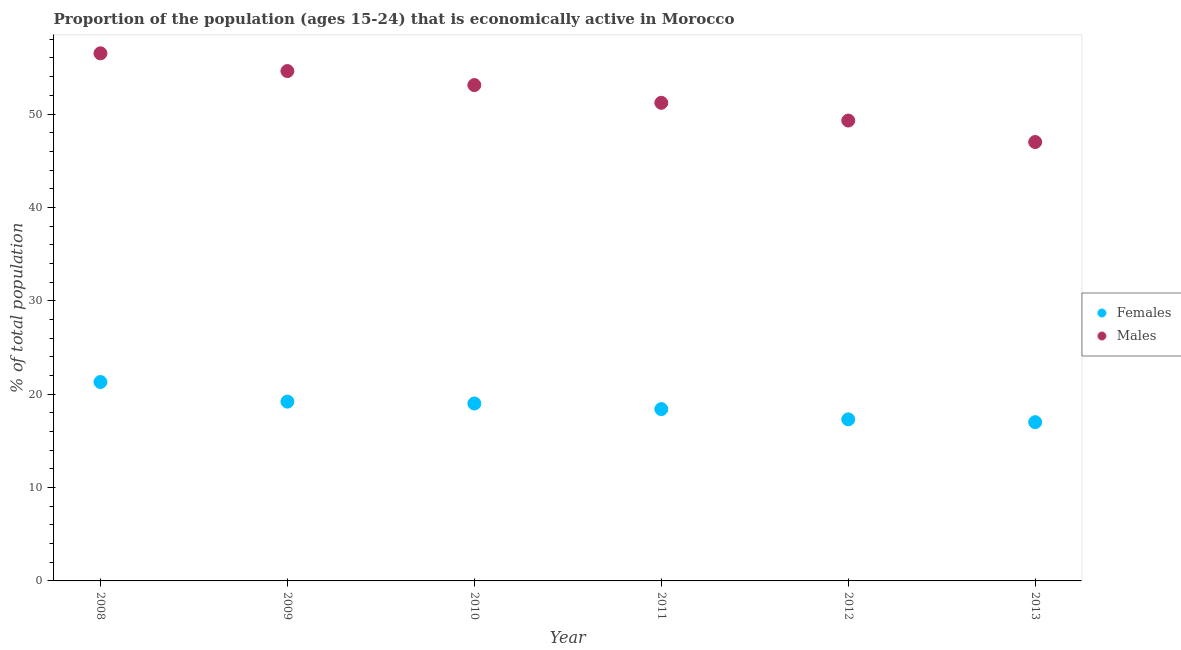How many different coloured dotlines are there?
Keep it short and to the point. 2. What is the percentage of economically active female population in 2008?
Your answer should be very brief. 21.3. Across all years, what is the maximum percentage of economically active male population?
Offer a terse response. 56.5. Across all years, what is the minimum percentage of economically active female population?
Your response must be concise. 17. In which year was the percentage of economically active female population maximum?
Ensure brevity in your answer.  2008. In which year was the percentage of economically active female population minimum?
Offer a very short reply. 2013. What is the total percentage of economically active male population in the graph?
Give a very brief answer. 311.7. What is the difference between the percentage of economically active male population in 2008 and that in 2010?
Keep it short and to the point. 3.4. What is the difference between the percentage of economically active male population in 2010 and the percentage of economically active female population in 2008?
Give a very brief answer. 31.8. What is the average percentage of economically active male population per year?
Give a very brief answer. 51.95. In the year 2011, what is the difference between the percentage of economically active male population and percentage of economically active female population?
Make the answer very short. 32.8. What is the ratio of the percentage of economically active female population in 2010 to that in 2012?
Offer a very short reply. 1.1. What is the difference between the highest and the second highest percentage of economically active female population?
Provide a succinct answer. 2.1. In how many years, is the percentage of economically active male population greater than the average percentage of economically active male population taken over all years?
Provide a succinct answer. 3. Is the sum of the percentage of economically active male population in 2010 and 2013 greater than the maximum percentage of economically active female population across all years?
Give a very brief answer. Yes. Does the percentage of economically active female population monotonically increase over the years?
Offer a very short reply. No. Is the percentage of economically active male population strictly greater than the percentage of economically active female population over the years?
Ensure brevity in your answer.  Yes. How many dotlines are there?
Give a very brief answer. 2. How many years are there in the graph?
Offer a very short reply. 6. Are the values on the major ticks of Y-axis written in scientific E-notation?
Give a very brief answer. No. Does the graph contain any zero values?
Make the answer very short. No. Does the graph contain grids?
Ensure brevity in your answer.  No. Where does the legend appear in the graph?
Your answer should be compact. Center right. What is the title of the graph?
Make the answer very short. Proportion of the population (ages 15-24) that is economically active in Morocco. Does "Primary completion rate" appear as one of the legend labels in the graph?
Provide a short and direct response. No. What is the label or title of the Y-axis?
Keep it short and to the point. % of total population. What is the % of total population of Females in 2008?
Make the answer very short. 21.3. What is the % of total population of Males in 2008?
Give a very brief answer. 56.5. What is the % of total population in Females in 2009?
Keep it short and to the point. 19.2. What is the % of total population of Males in 2009?
Offer a terse response. 54.6. What is the % of total population in Males in 2010?
Your answer should be compact. 53.1. What is the % of total population in Females in 2011?
Make the answer very short. 18.4. What is the % of total population of Males in 2011?
Your response must be concise. 51.2. What is the % of total population of Females in 2012?
Give a very brief answer. 17.3. What is the % of total population of Males in 2012?
Give a very brief answer. 49.3. What is the % of total population of Females in 2013?
Provide a succinct answer. 17. What is the % of total population of Males in 2013?
Offer a very short reply. 47. Across all years, what is the maximum % of total population of Females?
Provide a succinct answer. 21.3. Across all years, what is the maximum % of total population of Males?
Offer a very short reply. 56.5. Across all years, what is the minimum % of total population of Males?
Keep it short and to the point. 47. What is the total % of total population of Females in the graph?
Provide a short and direct response. 112.2. What is the total % of total population of Males in the graph?
Make the answer very short. 311.7. What is the difference between the % of total population of Females in 2008 and that in 2009?
Offer a terse response. 2.1. What is the difference between the % of total population of Males in 2008 and that in 2009?
Keep it short and to the point. 1.9. What is the difference between the % of total population in Females in 2008 and that in 2010?
Offer a terse response. 2.3. What is the difference between the % of total population in Females in 2008 and that in 2011?
Provide a succinct answer. 2.9. What is the difference between the % of total population in Females in 2008 and that in 2012?
Your response must be concise. 4. What is the difference between the % of total population in Females in 2008 and that in 2013?
Your answer should be very brief. 4.3. What is the difference between the % of total population of Females in 2009 and that in 2012?
Make the answer very short. 1.9. What is the difference between the % of total population in Males in 2009 and that in 2012?
Offer a terse response. 5.3. What is the difference between the % of total population in Females in 2009 and that in 2013?
Keep it short and to the point. 2.2. What is the difference between the % of total population of Males in 2009 and that in 2013?
Provide a short and direct response. 7.6. What is the difference between the % of total population of Males in 2010 and that in 2012?
Your answer should be compact. 3.8. What is the difference between the % of total population of Males in 2010 and that in 2013?
Provide a short and direct response. 6.1. What is the difference between the % of total population in Females in 2011 and that in 2012?
Offer a terse response. 1.1. What is the difference between the % of total population of Females in 2012 and that in 2013?
Your response must be concise. 0.3. What is the difference between the % of total population of Males in 2012 and that in 2013?
Your response must be concise. 2.3. What is the difference between the % of total population of Females in 2008 and the % of total population of Males in 2009?
Ensure brevity in your answer.  -33.3. What is the difference between the % of total population in Females in 2008 and the % of total population in Males in 2010?
Ensure brevity in your answer.  -31.8. What is the difference between the % of total population in Females in 2008 and the % of total population in Males in 2011?
Provide a succinct answer. -29.9. What is the difference between the % of total population in Females in 2008 and the % of total population in Males in 2013?
Provide a short and direct response. -25.7. What is the difference between the % of total population in Females in 2009 and the % of total population in Males in 2010?
Offer a terse response. -33.9. What is the difference between the % of total population of Females in 2009 and the % of total population of Males in 2011?
Give a very brief answer. -32. What is the difference between the % of total population of Females in 2009 and the % of total population of Males in 2012?
Keep it short and to the point. -30.1. What is the difference between the % of total population of Females in 2009 and the % of total population of Males in 2013?
Your answer should be compact. -27.8. What is the difference between the % of total population of Females in 2010 and the % of total population of Males in 2011?
Give a very brief answer. -32.2. What is the difference between the % of total population in Females in 2010 and the % of total population in Males in 2012?
Make the answer very short. -30.3. What is the difference between the % of total population in Females in 2010 and the % of total population in Males in 2013?
Give a very brief answer. -28. What is the difference between the % of total population of Females in 2011 and the % of total population of Males in 2012?
Your response must be concise. -30.9. What is the difference between the % of total population in Females in 2011 and the % of total population in Males in 2013?
Offer a terse response. -28.6. What is the difference between the % of total population of Females in 2012 and the % of total population of Males in 2013?
Your answer should be compact. -29.7. What is the average % of total population in Females per year?
Provide a short and direct response. 18.7. What is the average % of total population in Males per year?
Provide a short and direct response. 51.95. In the year 2008, what is the difference between the % of total population in Females and % of total population in Males?
Your response must be concise. -35.2. In the year 2009, what is the difference between the % of total population of Females and % of total population of Males?
Your response must be concise. -35.4. In the year 2010, what is the difference between the % of total population of Females and % of total population of Males?
Provide a succinct answer. -34.1. In the year 2011, what is the difference between the % of total population in Females and % of total population in Males?
Offer a very short reply. -32.8. In the year 2012, what is the difference between the % of total population in Females and % of total population in Males?
Offer a very short reply. -32. What is the ratio of the % of total population in Females in 2008 to that in 2009?
Keep it short and to the point. 1.11. What is the ratio of the % of total population in Males in 2008 to that in 2009?
Your answer should be compact. 1.03. What is the ratio of the % of total population of Females in 2008 to that in 2010?
Offer a terse response. 1.12. What is the ratio of the % of total population of Males in 2008 to that in 2010?
Ensure brevity in your answer.  1.06. What is the ratio of the % of total population of Females in 2008 to that in 2011?
Offer a very short reply. 1.16. What is the ratio of the % of total population in Males in 2008 to that in 2011?
Provide a short and direct response. 1.1. What is the ratio of the % of total population of Females in 2008 to that in 2012?
Offer a terse response. 1.23. What is the ratio of the % of total population in Males in 2008 to that in 2012?
Make the answer very short. 1.15. What is the ratio of the % of total population of Females in 2008 to that in 2013?
Give a very brief answer. 1.25. What is the ratio of the % of total population of Males in 2008 to that in 2013?
Make the answer very short. 1.2. What is the ratio of the % of total population of Females in 2009 to that in 2010?
Your response must be concise. 1.01. What is the ratio of the % of total population of Males in 2009 to that in 2010?
Offer a terse response. 1.03. What is the ratio of the % of total population of Females in 2009 to that in 2011?
Provide a succinct answer. 1.04. What is the ratio of the % of total population in Males in 2009 to that in 2011?
Make the answer very short. 1.07. What is the ratio of the % of total population in Females in 2009 to that in 2012?
Give a very brief answer. 1.11. What is the ratio of the % of total population of Males in 2009 to that in 2012?
Make the answer very short. 1.11. What is the ratio of the % of total population of Females in 2009 to that in 2013?
Ensure brevity in your answer.  1.13. What is the ratio of the % of total population of Males in 2009 to that in 2013?
Give a very brief answer. 1.16. What is the ratio of the % of total population in Females in 2010 to that in 2011?
Offer a very short reply. 1.03. What is the ratio of the % of total population of Males in 2010 to that in 2011?
Make the answer very short. 1.04. What is the ratio of the % of total population in Females in 2010 to that in 2012?
Your response must be concise. 1.1. What is the ratio of the % of total population in Males in 2010 to that in 2012?
Your answer should be compact. 1.08. What is the ratio of the % of total population of Females in 2010 to that in 2013?
Offer a very short reply. 1.12. What is the ratio of the % of total population in Males in 2010 to that in 2013?
Your answer should be compact. 1.13. What is the ratio of the % of total population in Females in 2011 to that in 2012?
Your answer should be compact. 1.06. What is the ratio of the % of total population of Females in 2011 to that in 2013?
Your answer should be compact. 1.08. What is the ratio of the % of total population in Males in 2011 to that in 2013?
Your response must be concise. 1.09. What is the ratio of the % of total population of Females in 2012 to that in 2013?
Give a very brief answer. 1.02. What is the ratio of the % of total population in Males in 2012 to that in 2013?
Provide a succinct answer. 1.05. What is the difference between the highest and the second highest % of total population in Females?
Offer a terse response. 2.1. What is the difference between the highest and the lowest % of total population of Females?
Keep it short and to the point. 4.3. 